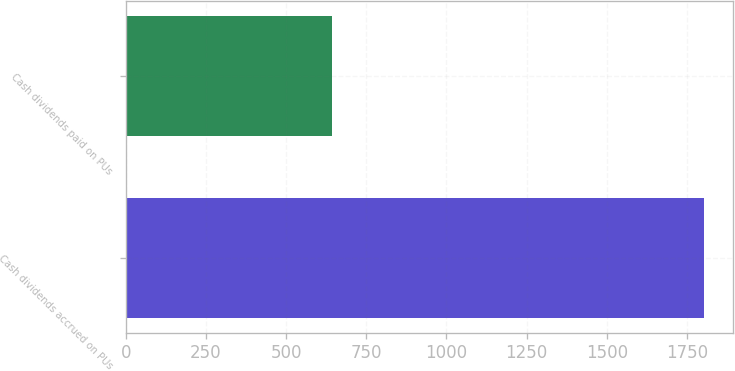<chart> <loc_0><loc_0><loc_500><loc_500><bar_chart><fcel>Cash dividends accrued on PUs<fcel>Cash dividends paid on PUs<nl><fcel>1804<fcel>644<nl></chart> 